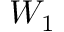<formula> <loc_0><loc_0><loc_500><loc_500>W _ { 1 }</formula> 